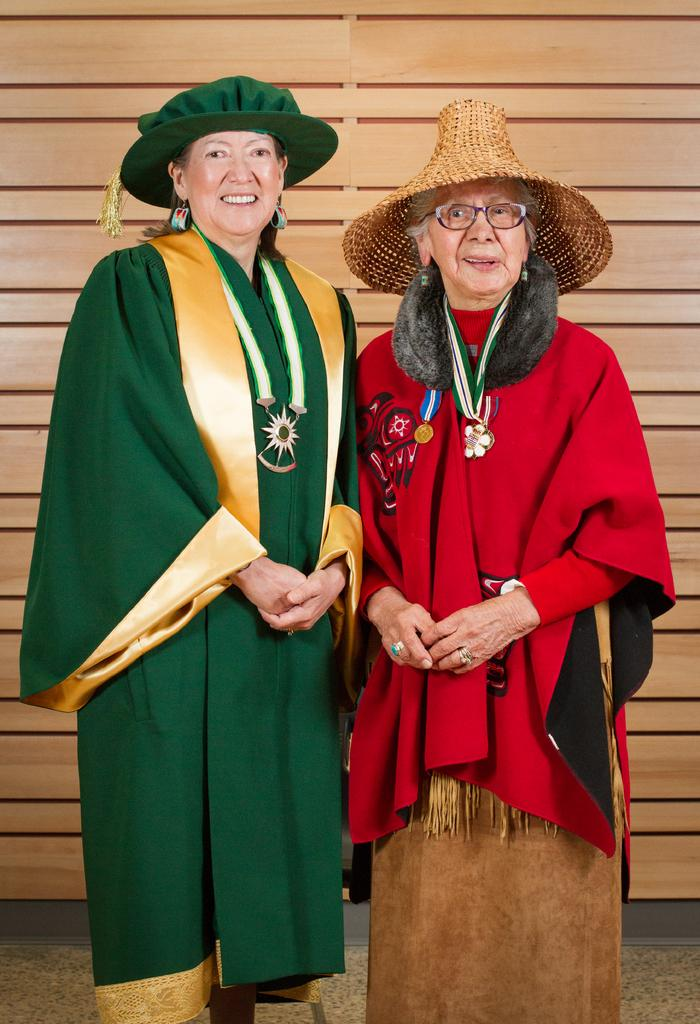How many ladies are in the image? There are two ladies in the image. What are the ladies doing in the image? Both ladies are standing. What are the ladies wearing on their heads? Both ladies are wearing hats. What accessories do the ladies have on their necks? Both ladies have tags with pendants. What is unique about the lady on the right? The lady on the right is wearing glasses. What can be seen in the background of the image? There is a wall in the background of the image. What type of class is being taught by the beggar in the image? There is no beggar present in the image, and therefore no class is being taught. What day of the week is it in the image? The day of the week is not mentioned or visible in the image. 